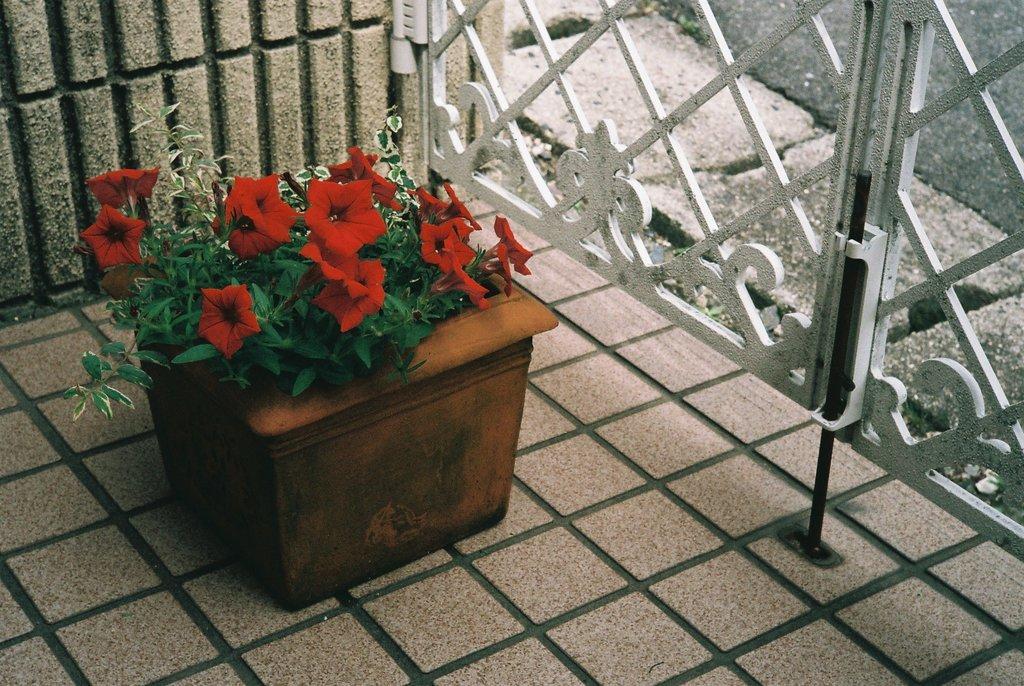Describe this image in one or two sentences. In the center of the image, we can see a flower pot and in the background, there is a gate. At the bottom, there is a road and a floor. 